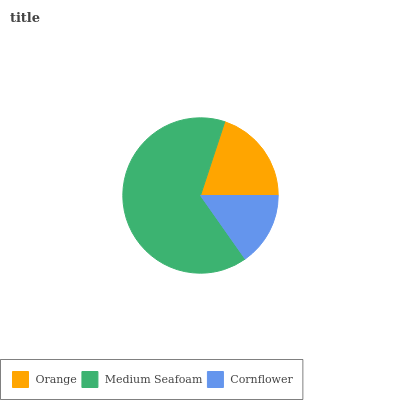Is Cornflower the minimum?
Answer yes or no. Yes. Is Medium Seafoam the maximum?
Answer yes or no. Yes. Is Medium Seafoam the minimum?
Answer yes or no. No. Is Cornflower the maximum?
Answer yes or no. No. Is Medium Seafoam greater than Cornflower?
Answer yes or no. Yes. Is Cornflower less than Medium Seafoam?
Answer yes or no. Yes. Is Cornflower greater than Medium Seafoam?
Answer yes or no. No. Is Medium Seafoam less than Cornflower?
Answer yes or no. No. Is Orange the high median?
Answer yes or no. Yes. Is Orange the low median?
Answer yes or no. Yes. Is Cornflower the high median?
Answer yes or no. No. Is Cornflower the low median?
Answer yes or no. No. 